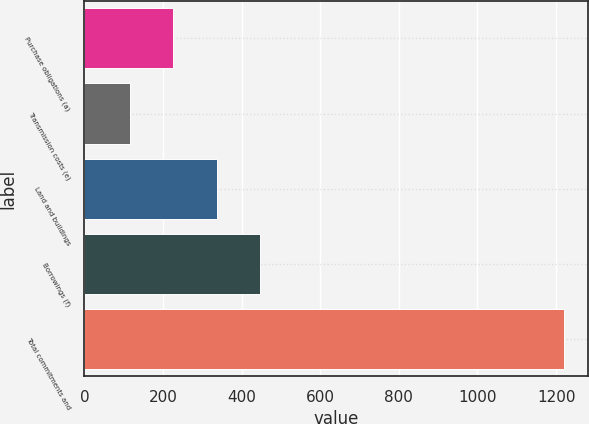<chart> <loc_0><loc_0><loc_500><loc_500><bar_chart><fcel>Purchase obligations (a)<fcel>Transmission costs (e)<fcel>Land and buildings<fcel>Borrowings (f)<fcel>Total commitments and<nl><fcel>225.6<fcel>115<fcel>336.2<fcel>446.8<fcel>1221<nl></chart> 